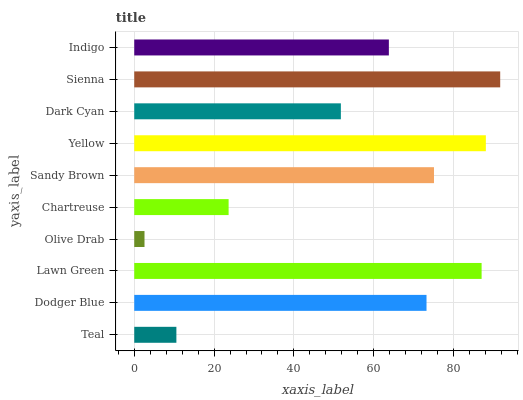Is Olive Drab the minimum?
Answer yes or no. Yes. Is Sienna the maximum?
Answer yes or no. Yes. Is Dodger Blue the minimum?
Answer yes or no. No. Is Dodger Blue the maximum?
Answer yes or no. No. Is Dodger Blue greater than Teal?
Answer yes or no. Yes. Is Teal less than Dodger Blue?
Answer yes or no. Yes. Is Teal greater than Dodger Blue?
Answer yes or no. No. Is Dodger Blue less than Teal?
Answer yes or no. No. Is Dodger Blue the high median?
Answer yes or no. Yes. Is Indigo the low median?
Answer yes or no. Yes. Is Lawn Green the high median?
Answer yes or no. No. Is Sandy Brown the low median?
Answer yes or no. No. 